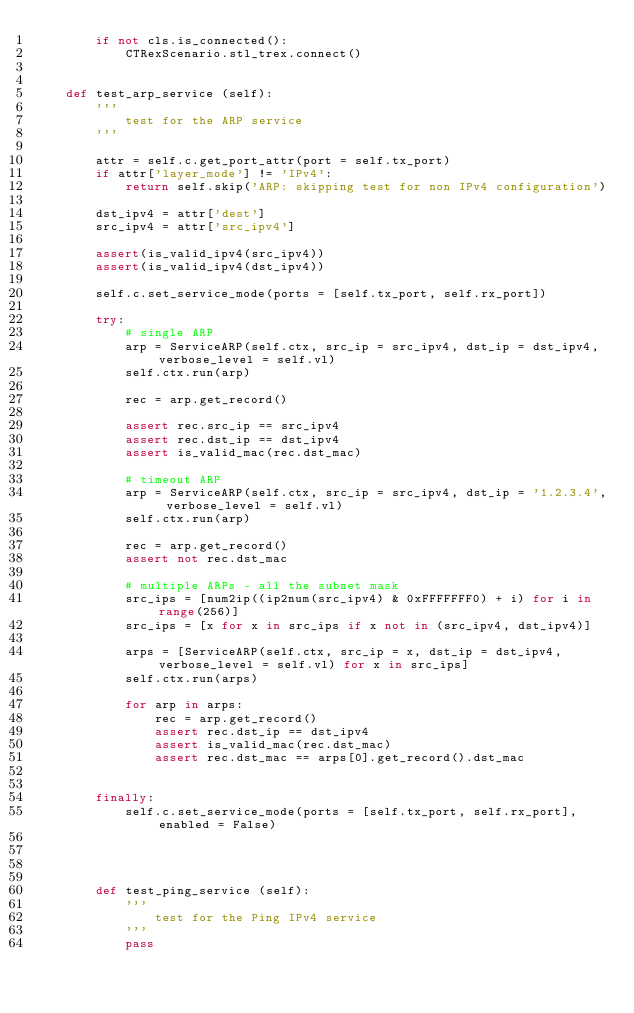<code> <loc_0><loc_0><loc_500><loc_500><_Python_>        if not cls.is_connected():
            CTRexScenario.stl_trex.connect()
            
             
    def test_arp_service (self):
        '''
            test for the ARP service
        '''
        
        attr = self.c.get_port_attr(port = self.tx_port)
        if attr['layer_mode'] != 'IPv4':
            return self.skip('ARP: skipping test for non IPv4 configuration')
        
        dst_ipv4 = attr['dest']
        src_ipv4 = attr['src_ipv4']
        
        assert(is_valid_ipv4(src_ipv4))
        assert(is_valid_ipv4(dst_ipv4))
        
        self.c.set_service_mode(ports = [self.tx_port, self.rx_port])
        
        try:
            # single ARP
            arp = ServiceARP(self.ctx, src_ip = src_ipv4, dst_ip = dst_ipv4, verbose_level = self.vl)
            self.ctx.run(arp)
            
            rec = arp.get_record()
            
            assert rec.src_ip == src_ipv4
            assert rec.dst_ip == dst_ipv4
            assert is_valid_mac(rec.dst_mac)
            
            # timeout ARP
            arp = ServiceARP(self.ctx, src_ip = src_ipv4, dst_ip = '1.2.3.4', verbose_level = self.vl)
            self.ctx.run(arp)

            rec = arp.get_record()
            assert not rec.dst_mac
            
            # multiple ARPs - all the subnet mask
            src_ips = [num2ip((ip2num(src_ipv4) & 0xFFFFFFF0) + i) for i in range(256)]
            src_ips = [x for x in src_ips if x not in (src_ipv4, dst_ipv4)]
            
            arps = [ServiceARP(self.ctx, src_ip = x, dst_ip = dst_ipv4, verbose_level = self.vl) for x in src_ips]
            self.ctx.run(arps)
        
            for arp in arps:
                rec = arp.get_record()
                assert rec.dst_ip == dst_ipv4
                assert is_valid_mac(rec.dst_mac)
                assert rec.dst_mac == arps[0].get_record().dst_mac
                
            
        finally:
            self.c.set_service_mode(ports = [self.tx_port, self.rx_port], enabled = False)

            
            
            
        def test_ping_service (self):
            '''
                test for the Ping IPv4 service
            '''
            pass
</code> 